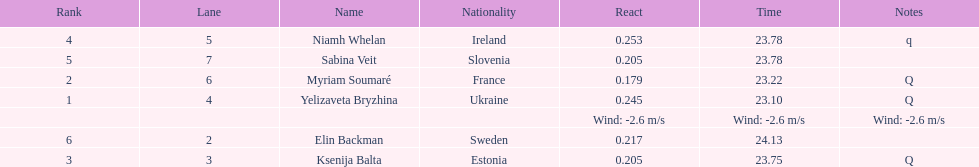Who finished after sabina veit? Elin Backman. 